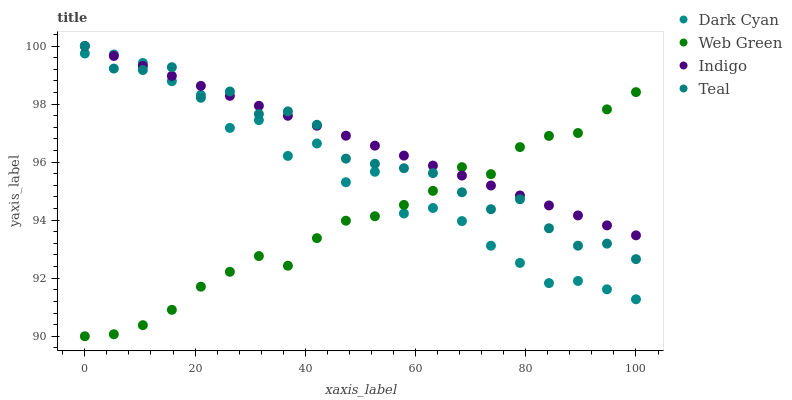Does Web Green have the minimum area under the curve?
Answer yes or no. Yes. Does Indigo have the maximum area under the curve?
Answer yes or no. Yes. Does Teal have the minimum area under the curve?
Answer yes or no. No. Does Teal have the maximum area under the curve?
Answer yes or no. No. Is Indigo the smoothest?
Answer yes or no. Yes. Is Dark Cyan the roughest?
Answer yes or no. Yes. Is Teal the smoothest?
Answer yes or no. No. Is Teal the roughest?
Answer yes or no. No. Does Web Green have the lowest value?
Answer yes or no. Yes. Does Teal have the lowest value?
Answer yes or no. No. Does Teal have the highest value?
Answer yes or no. Yes. Does Web Green have the highest value?
Answer yes or no. No. Does Teal intersect Indigo?
Answer yes or no. Yes. Is Teal less than Indigo?
Answer yes or no. No. Is Teal greater than Indigo?
Answer yes or no. No. 